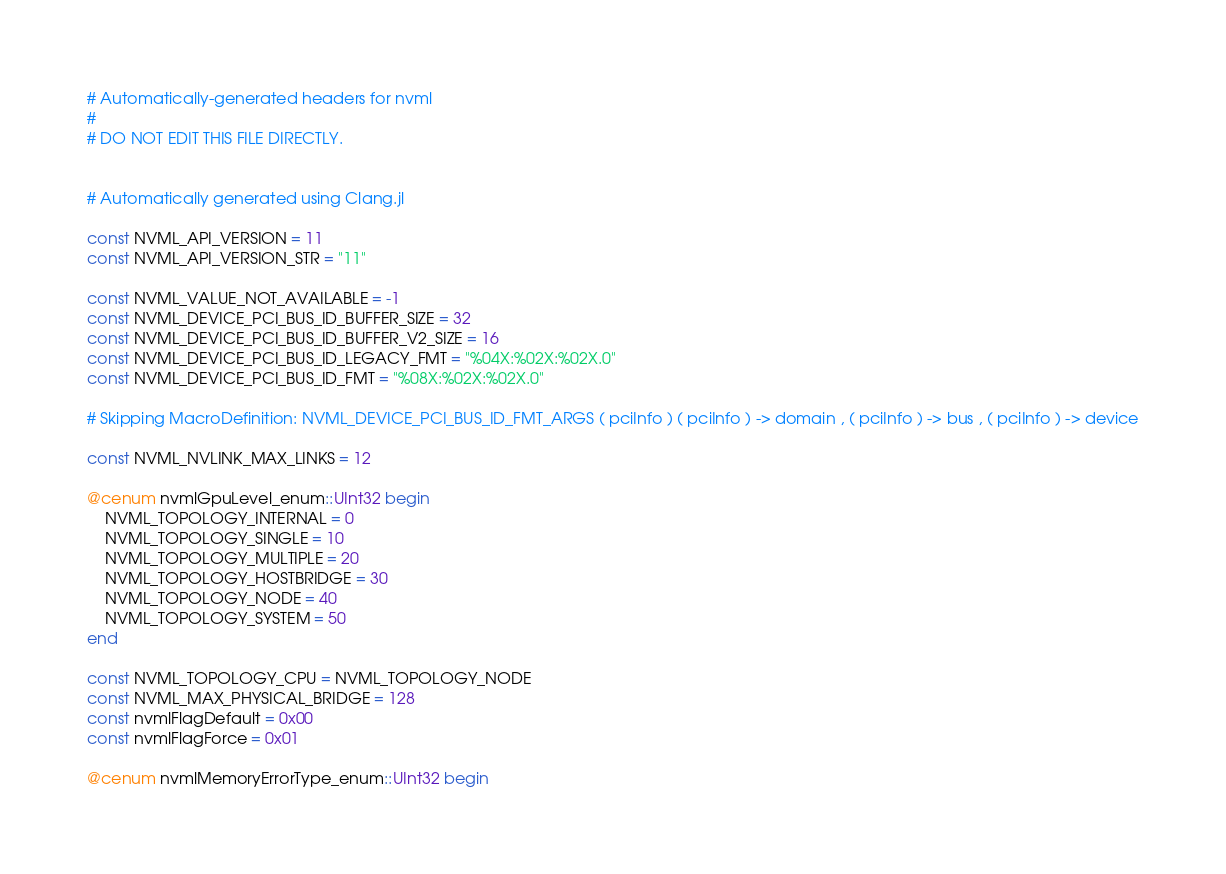<code> <loc_0><loc_0><loc_500><loc_500><_Julia_># Automatically-generated headers for nvml
#
# DO NOT EDIT THIS FILE DIRECTLY.


# Automatically generated using Clang.jl

const NVML_API_VERSION = 11
const NVML_API_VERSION_STR = "11"

const NVML_VALUE_NOT_AVAILABLE = -1
const NVML_DEVICE_PCI_BUS_ID_BUFFER_SIZE = 32
const NVML_DEVICE_PCI_BUS_ID_BUFFER_V2_SIZE = 16
const NVML_DEVICE_PCI_BUS_ID_LEGACY_FMT = "%04X:%02X:%02X.0"
const NVML_DEVICE_PCI_BUS_ID_FMT = "%08X:%02X:%02X.0"

# Skipping MacroDefinition: NVML_DEVICE_PCI_BUS_ID_FMT_ARGS ( pciInfo ) ( pciInfo ) -> domain , ( pciInfo ) -> bus , ( pciInfo ) -> device

const NVML_NVLINK_MAX_LINKS = 12

@cenum nvmlGpuLevel_enum::UInt32 begin
    NVML_TOPOLOGY_INTERNAL = 0
    NVML_TOPOLOGY_SINGLE = 10
    NVML_TOPOLOGY_MULTIPLE = 20
    NVML_TOPOLOGY_HOSTBRIDGE = 30
    NVML_TOPOLOGY_NODE = 40
    NVML_TOPOLOGY_SYSTEM = 50
end

const NVML_TOPOLOGY_CPU = NVML_TOPOLOGY_NODE
const NVML_MAX_PHYSICAL_BRIDGE = 128
const nvmlFlagDefault = 0x00
const nvmlFlagForce = 0x01

@cenum nvmlMemoryErrorType_enum::UInt32 begin</code> 